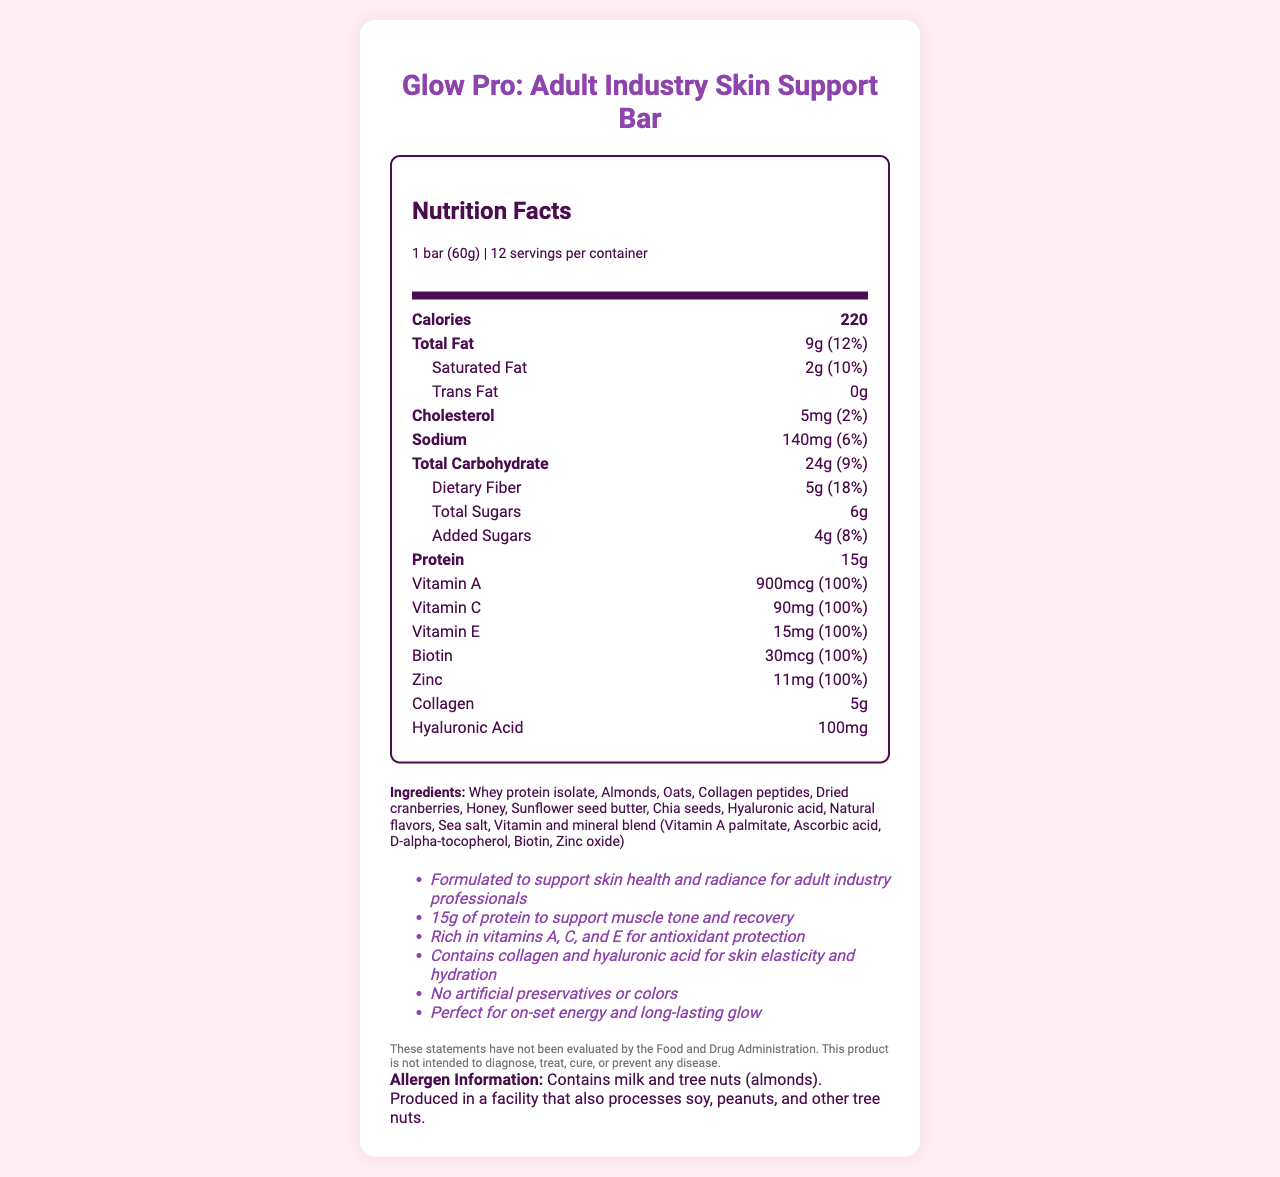what is the serving size of the Glow Pro bar? The serving size is clearly listed as "1 bar (60g)" at the top of the Nutrition Facts.
Answer: 1 bar (60g) how many servings are there in one container? The document mentions there are 12 servings per container.
Answer: 12 what is the total fiber content per serving? Under the total carbohydrate section, the dietary fiber content is listed as 5g.
Answer: 5g what are the ingredients listed for the Glow Pro bar? The ingredients are listed towards the bottom of the document under the "Ingredients" section.
Answer: Whey protein isolate, Almonds, Oats, Collagen peptides, Dried cranberries, Honey, Sunflower seed butter, Chia seeds, Hyaluronic acid, Natural flavors, Sea salt, Vitamin and mineral blend (Vitamin A palmitate, Ascorbic acid, D-alpha-tocopherol, Biotin, Zinc oxide) which nutrients have a daily value percentage of 100%? The vitamins A, C, E, Biotin and Zinc all have a daily value percentage of 100% as listed under their respective rows in the Nutrition Facts.
Answer: Vitamin A, Vitamin C, Vitamin E, Biotin, Zinc what is the total amount of cholesterol in each serving? The amount of cholesterol per serving is listed as 5mg.
Answer: 5mg how much protein does one bar contain? The protein content is listed as 15g.
Answer: 15g select the correct combination of allergens present in the bar: i) Milk ii) Soy iii) Peanuts iv) Tree nuts The allergen information states that the bar contains milk and tree nuts (almonds).
Answer: i) Milk iv) Tree nuts how many calories are there in one serving of the Glow Pro Bar? The calorie content per serving is listed as 220 calories.
Answer: 220 what is the percentage of daily value of sodium in one serving? A. 2% B. 6% C. 10% The sodium content is provided as 140mg, which constitutes 6% of the daily value.
Answer: B. 6% is there any trans fat in the Glow Pro Bar? The trans fat content is listed as 0g, indicating there is no trans fat in the bar.
Answer: No summarize the health benefits promoted by the Glow Pro Bar. The summary condenses the key marketing claims and health benefits as outlined throughout the document, emphasizing the targeted audience, key nutrients, and benefits.
Answer: The Glow Pro Bar is marketed to adult industry professionals and claims to support skin health and radiance, provide 15g of protein for muscle tone and recovery, and offer antioxidant protection with vitamins A, C, and E. The bar also contains collagen and hyaluronic acid for skin elasticity and hydration, has no artificial preservatives or colors, and is positioned as a product providing on-set energy and a long-lasting glow. how much total fat is there in one bar? The total fat content per serving is listed as 9g.
Answer: 9g can this document be relied upon to claim that the bar can diagnose, treat, cure, or prevent any disease? The disclaimer at the bottom clearly states that the statements have not been evaluated by the FDA and the product is not intended to diagnose, treat, cure, or prevent any disease.
Answer: No what is the intended target market for the Glow Pro Bar? The marketing claims specifically state that the product is formulated to support skin health and radiance for adult industry professionals.
Answer: Adult industry professionals what is the main source of protein in the Glow Pro bar? The first ingredient listed is Whey protein isolate, which is a primary source of protein in the bar.
Answer: Whey protein isolate 